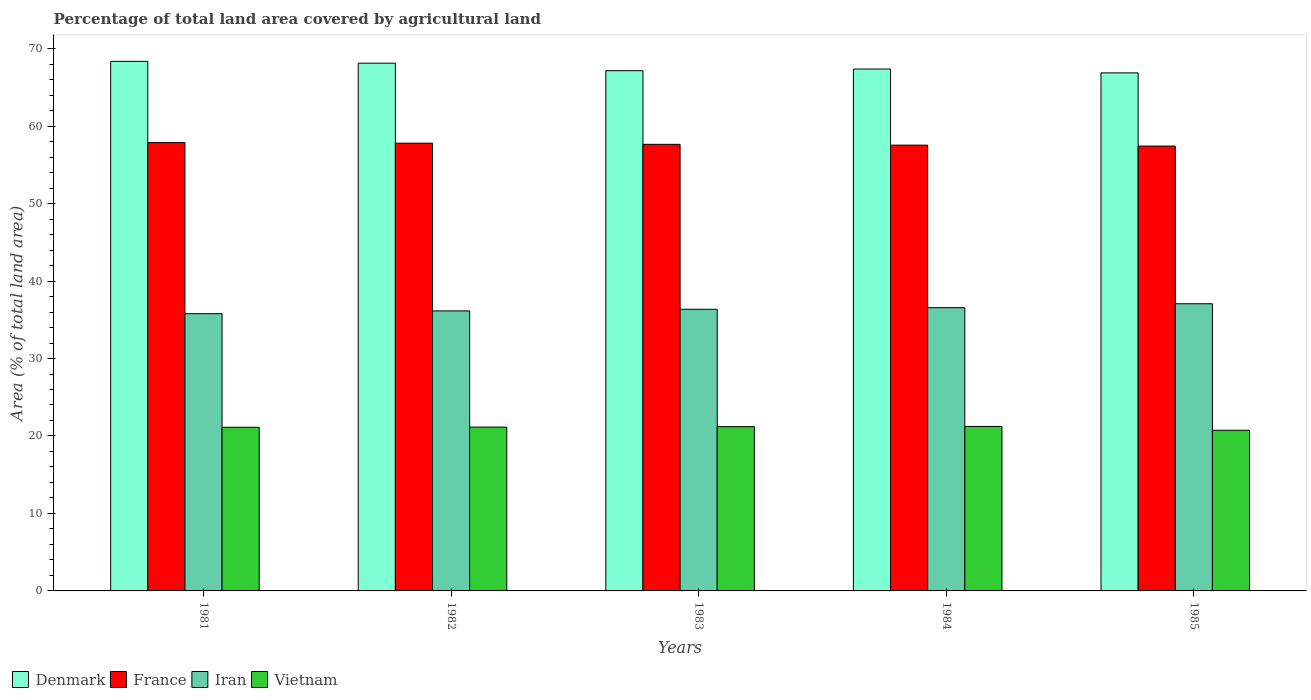Are the number of bars per tick equal to the number of legend labels?
Offer a terse response. Yes. What is the percentage of agricultural land in Denmark in 1981?
Give a very brief answer. 68.36. Across all years, what is the maximum percentage of agricultural land in Denmark?
Provide a succinct answer. 68.36. Across all years, what is the minimum percentage of agricultural land in Vietnam?
Offer a very short reply. 20.74. In which year was the percentage of agricultural land in Vietnam minimum?
Your answer should be compact. 1985. What is the total percentage of agricultural land in Vietnam in the graph?
Make the answer very short. 105.45. What is the difference between the percentage of agricultural land in France in 1982 and that in 1984?
Your answer should be compact. 0.25. What is the difference between the percentage of agricultural land in Vietnam in 1982 and the percentage of agricultural land in Denmark in 1984?
Keep it short and to the point. -46.22. What is the average percentage of agricultural land in Denmark per year?
Provide a succinct answer. 67.57. In the year 1981, what is the difference between the percentage of agricultural land in Vietnam and percentage of agricultural land in Iran?
Give a very brief answer. -14.66. In how many years, is the percentage of agricultural land in Vietnam greater than 66 %?
Keep it short and to the point. 0. What is the ratio of the percentage of agricultural land in France in 1983 to that in 1984?
Keep it short and to the point. 1. Is the percentage of agricultural land in Iran in 1981 less than that in 1983?
Your answer should be very brief. Yes. What is the difference between the highest and the second highest percentage of agricultural land in Denmark?
Keep it short and to the point. 0.24. What is the difference between the highest and the lowest percentage of agricultural land in Iran?
Provide a succinct answer. 1.28. In how many years, is the percentage of agricultural land in Denmark greater than the average percentage of agricultural land in Denmark taken over all years?
Your response must be concise. 2. Is the sum of the percentage of agricultural land in Iran in 1984 and 1985 greater than the maximum percentage of agricultural land in France across all years?
Offer a very short reply. Yes. Is it the case that in every year, the sum of the percentage of agricultural land in Iran and percentage of agricultural land in Denmark is greater than the sum of percentage of agricultural land in Vietnam and percentage of agricultural land in France?
Make the answer very short. Yes. What does the 4th bar from the left in 1985 represents?
Provide a short and direct response. Vietnam. What does the 2nd bar from the right in 1985 represents?
Ensure brevity in your answer.  Iran. Is it the case that in every year, the sum of the percentage of agricultural land in Denmark and percentage of agricultural land in Vietnam is greater than the percentage of agricultural land in France?
Keep it short and to the point. Yes. How many bars are there?
Give a very brief answer. 20. Are the values on the major ticks of Y-axis written in scientific E-notation?
Provide a short and direct response. No. Does the graph contain any zero values?
Your response must be concise. No. Does the graph contain grids?
Make the answer very short. No. Where does the legend appear in the graph?
Your response must be concise. Bottom left. How are the legend labels stacked?
Offer a very short reply. Horizontal. What is the title of the graph?
Offer a terse response. Percentage of total land area covered by agricultural land. What is the label or title of the X-axis?
Your answer should be compact. Years. What is the label or title of the Y-axis?
Provide a short and direct response. Area (% of total land area). What is the Area (% of total land area) in Denmark in 1981?
Offer a terse response. 68.36. What is the Area (% of total land area) of France in 1981?
Make the answer very short. 57.87. What is the Area (% of total land area) of Iran in 1981?
Provide a succinct answer. 35.79. What is the Area (% of total land area) of Vietnam in 1981?
Make the answer very short. 21.13. What is the Area (% of total land area) in Denmark in 1982?
Your answer should be very brief. 68.12. What is the Area (% of total land area) in France in 1982?
Offer a terse response. 57.79. What is the Area (% of total land area) in Iran in 1982?
Offer a terse response. 36.15. What is the Area (% of total land area) in Vietnam in 1982?
Your answer should be very brief. 21.15. What is the Area (% of total land area) of Denmark in 1983?
Your answer should be very brief. 67.15. What is the Area (% of total land area) of France in 1983?
Your answer should be very brief. 57.65. What is the Area (% of total land area) of Iran in 1983?
Keep it short and to the point. 36.36. What is the Area (% of total land area) of Vietnam in 1983?
Provide a succinct answer. 21.2. What is the Area (% of total land area) of Denmark in 1984?
Offer a terse response. 67.37. What is the Area (% of total land area) of France in 1984?
Provide a short and direct response. 57.54. What is the Area (% of total land area) of Iran in 1984?
Your response must be concise. 36.56. What is the Area (% of total land area) in Vietnam in 1984?
Provide a short and direct response. 21.23. What is the Area (% of total land area) of Denmark in 1985?
Your response must be concise. 66.87. What is the Area (% of total land area) of France in 1985?
Your answer should be compact. 57.42. What is the Area (% of total land area) in Iran in 1985?
Make the answer very short. 37.07. What is the Area (% of total land area) in Vietnam in 1985?
Provide a succinct answer. 20.74. Across all years, what is the maximum Area (% of total land area) in Denmark?
Provide a short and direct response. 68.36. Across all years, what is the maximum Area (% of total land area) of France?
Ensure brevity in your answer.  57.87. Across all years, what is the maximum Area (% of total land area) in Iran?
Keep it short and to the point. 37.07. Across all years, what is the maximum Area (% of total land area) in Vietnam?
Provide a short and direct response. 21.23. Across all years, what is the minimum Area (% of total land area) in Denmark?
Provide a succinct answer. 66.87. Across all years, what is the minimum Area (% of total land area) in France?
Keep it short and to the point. 57.42. Across all years, what is the minimum Area (% of total land area) of Iran?
Provide a short and direct response. 35.79. Across all years, what is the minimum Area (% of total land area) of Vietnam?
Keep it short and to the point. 20.74. What is the total Area (% of total land area) of Denmark in the graph?
Provide a short and direct response. 337.87. What is the total Area (% of total land area) in France in the graph?
Provide a succinct answer. 288.27. What is the total Area (% of total land area) in Iran in the graph?
Make the answer very short. 181.92. What is the total Area (% of total land area) of Vietnam in the graph?
Make the answer very short. 105.45. What is the difference between the Area (% of total land area) of Denmark in 1981 and that in 1982?
Provide a short and direct response. 0.24. What is the difference between the Area (% of total land area) in France in 1981 and that in 1982?
Provide a succinct answer. 0.07. What is the difference between the Area (% of total land area) of Iran in 1981 and that in 1982?
Your answer should be very brief. -0.36. What is the difference between the Area (% of total land area) in Vietnam in 1981 and that in 1982?
Your response must be concise. -0.02. What is the difference between the Area (% of total land area) of Denmark in 1981 and that in 1983?
Make the answer very short. 1.2. What is the difference between the Area (% of total land area) of France in 1981 and that in 1983?
Ensure brevity in your answer.  0.22. What is the difference between the Area (% of total land area) of Iran in 1981 and that in 1983?
Your answer should be compact. -0.57. What is the difference between the Area (% of total land area) in Vietnam in 1981 and that in 1983?
Give a very brief answer. -0.08. What is the difference between the Area (% of total land area) of France in 1981 and that in 1984?
Your answer should be very brief. 0.33. What is the difference between the Area (% of total land area) in Iran in 1981 and that in 1984?
Offer a very short reply. -0.77. What is the difference between the Area (% of total land area) of Vietnam in 1981 and that in 1984?
Offer a very short reply. -0.1. What is the difference between the Area (% of total land area) of Denmark in 1981 and that in 1985?
Keep it short and to the point. 1.49. What is the difference between the Area (% of total land area) in France in 1981 and that in 1985?
Offer a terse response. 0.45. What is the difference between the Area (% of total land area) of Iran in 1981 and that in 1985?
Ensure brevity in your answer.  -1.28. What is the difference between the Area (% of total land area) in Vietnam in 1981 and that in 1985?
Give a very brief answer. 0.39. What is the difference between the Area (% of total land area) in Denmark in 1982 and that in 1983?
Provide a succinct answer. 0.97. What is the difference between the Area (% of total land area) in France in 1982 and that in 1983?
Your answer should be very brief. 0.15. What is the difference between the Area (% of total land area) in Iran in 1982 and that in 1983?
Your response must be concise. -0.21. What is the difference between the Area (% of total land area) of Vietnam in 1982 and that in 1983?
Your answer should be very brief. -0.06. What is the difference between the Area (% of total land area) of Denmark in 1982 and that in 1984?
Keep it short and to the point. 0.76. What is the difference between the Area (% of total land area) of France in 1982 and that in 1984?
Your response must be concise. 0.25. What is the difference between the Area (% of total land area) of Iran in 1982 and that in 1984?
Offer a terse response. -0.41. What is the difference between the Area (% of total land area) of Vietnam in 1982 and that in 1984?
Provide a succinct answer. -0.08. What is the difference between the Area (% of total land area) in Denmark in 1982 and that in 1985?
Your answer should be compact. 1.25. What is the difference between the Area (% of total land area) in France in 1982 and that in 1985?
Provide a succinct answer. 0.37. What is the difference between the Area (% of total land area) of Iran in 1982 and that in 1985?
Provide a succinct answer. -0.92. What is the difference between the Area (% of total land area) in Vietnam in 1982 and that in 1985?
Your response must be concise. 0.41. What is the difference between the Area (% of total land area) of Denmark in 1983 and that in 1984?
Ensure brevity in your answer.  -0.21. What is the difference between the Area (% of total land area) of France in 1983 and that in 1984?
Provide a succinct answer. 0.1. What is the difference between the Area (% of total land area) of Iran in 1983 and that in 1984?
Give a very brief answer. -0.2. What is the difference between the Area (% of total land area) of Vietnam in 1983 and that in 1984?
Provide a short and direct response. -0.02. What is the difference between the Area (% of total land area) of Denmark in 1983 and that in 1985?
Your answer should be very brief. 0.28. What is the difference between the Area (% of total land area) in France in 1983 and that in 1985?
Ensure brevity in your answer.  0.22. What is the difference between the Area (% of total land area) in Iran in 1983 and that in 1985?
Keep it short and to the point. -0.71. What is the difference between the Area (% of total land area) in Vietnam in 1983 and that in 1985?
Keep it short and to the point. 0.47. What is the difference between the Area (% of total land area) in Denmark in 1984 and that in 1985?
Give a very brief answer. 0.5. What is the difference between the Area (% of total land area) of France in 1984 and that in 1985?
Ensure brevity in your answer.  0.12. What is the difference between the Area (% of total land area) of Iran in 1984 and that in 1985?
Provide a short and direct response. -0.51. What is the difference between the Area (% of total land area) in Vietnam in 1984 and that in 1985?
Your answer should be very brief. 0.49. What is the difference between the Area (% of total land area) in Denmark in 1981 and the Area (% of total land area) in France in 1982?
Provide a short and direct response. 10.56. What is the difference between the Area (% of total land area) in Denmark in 1981 and the Area (% of total land area) in Iran in 1982?
Make the answer very short. 32.21. What is the difference between the Area (% of total land area) of Denmark in 1981 and the Area (% of total land area) of Vietnam in 1982?
Make the answer very short. 47.21. What is the difference between the Area (% of total land area) in France in 1981 and the Area (% of total land area) in Iran in 1982?
Provide a succinct answer. 21.72. What is the difference between the Area (% of total land area) of France in 1981 and the Area (% of total land area) of Vietnam in 1982?
Make the answer very short. 36.72. What is the difference between the Area (% of total land area) of Iran in 1981 and the Area (% of total land area) of Vietnam in 1982?
Your answer should be very brief. 14.64. What is the difference between the Area (% of total land area) in Denmark in 1981 and the Area (% of total land area) in France in 1983?
Keep it short and to the point. 10.71. What is the difference between the Area (% of total land area) of Denmark in 1981 and the Area (% of total land area) of Iran in 1983?
Your answer should be very brief. 32. What is the difference between the Area (% of total land area) of Denmark in 1981 and the Area (% of total land area) of Vietnam in 1983?
Your response must be concise. 47.15. What is the difference between the Area (% of total land area) in France in 1981 and the Area (% of total land area) in Iran in 1983?
Give a very brief answer. 21.51. What is the difference between the Area (% of total land area) of France in 1981 and the Area (% of total land area) of Vietnam in 1983?
Your response must be concise. 36.66. What is the difference between the Area (% of total land area) of Iran in 1981 and the Area (% of total land area) of Vietnam in 1983?
Ensure brevity in your answer.  14.58. What is the difference between the Area (% of total land area) in Denmark in 1981 and the Area (% of total land area) in France in 1984?
Make the answer very short. 10.82. What is the difference between the Area (% of total land area) of Denmark in 1981 and the Area (% of total land area) of Iran in 1984?
Your response must be concise. 31.8. What is the difference between the Area (% of total land area) of Denmark in 1981 and the Area (% of total land area) of Vietnam in 1984?
Your answer should be very brief. 47.13. What is the difference between the Area (% of total land area) of France in 1981 and the Area (% of total land area) of Iran in 1984?
Give a very brief answer. 21.31. What is the difference between the Area (% of total land area) of France in 1981 and the Area (% of total land area) of Vietnam in 1984?
Give a very brief answer. 36.64. What is the difference between the Area (% of total land area) of Iran in 1981 and the Area (% of total land area) of Vietnam in 1984?
Give a very brief answer. 14.56. What is the difference between the Area (% of total land area) in Denmark in 1981 and the Area (% of total land area) in France in 1985?
Give a very brief answer. 10.94. What is the difference between the Area (% of total land area) in Denmark in 1981 and the Area (% of total land area) in Iran in 1985?
Offer a terse response. 31.29. What is the difference between the Area (% of total land area) of Denmark in 1981 and the Area (% of total land area) of Vietnam in 1985?
Offer a very short reply. 47.62. What is the difference between the Area (% of total land area) of France in 1981 and the Area (% of total land area) of Iran in 1985?
Your answer should be very brief. 20.8. What is the difference between the Area (% of total land area) in France in 1981 and the Area (% of total land area) in Vietnam in 1985?
Your answer should be compact. 37.13. What is the difference between the Area (% of total land area) of Iran in 1981 and the Area (% of total land area) of Vietnam in 1985?
Ensure brevity in your answer.  15.05. What is the difference between the Area (% of total land area) in Denmark in 1982 and the Area (% of total land area) in France in 1983?
Your response must be concise. 10.48. What is the difference between the Area (% of total land area) of Denmark in 1982 and the Area (% of total land area) of Iran in 1983?
Offer a terse response. 31.76. What is the difference between the Area (% of total land area) of Denmark in 1982 and the Area (% of total land area) of Vietnam in 1983?
Offer a very short reply. 46.92. What is the difference between the Area (% of total land area) of France in 1982 and the Area (% of total land area) of Iran in 1983?
Give a very brief answer. 21.44. What is the difference between the Area (% of total land area) of France in 1982 and the Area (% of total land area) of Vietnam in 1983?
Provide a short and direct response. 36.59. What is the difference between the Area (% of total land area) in Iran in 1982 and the Area (% of total land area) in Vietnam in 1983?
Provide a succinct answer. 14.94. What is the difference between the Area (% of total land area) of Denmark in 1982 and the Area (% of total land area) of France in 1984?
Your response must be concise. 10.58. What is the difference between the Area (% of total land area) in Denmark in 1982 and the Area (% of total land area) in Iran in 1984?
Your response must be concise. 31.56. What is the difference between the Area (% of total land area) of Denmark in 1982 and the Area (% of total land area) of Vietnam in 1984?
Offer a very short reply. 46.89. What is the difference between the Area (% of total land area) in France in 1982 and the Area (% of total land area) in Iran in 1984?
Provide a short and direct response. 21.23. What is the difference between the Area (% of total land area) in France in 1982 and the Area (% of total land area) in Vietnam in 1984?
Your response must be concise. 36.56. What is the difference between the Area (% of total land area) of Iran in 1982 and the Area (% of total land area) of Vietnam in 1984?
Make the answer very short. 14.92. What is the difference between the Area (% of total land area) of Denmark in 1982 and the Area (% of total land area) of France in 1985?
Offer a terse response. 10.7. What is the difference between the Area (% of total land area) in Denmark in 1982 and the Area (% of total land area) in Iran in 1985?
Your answer should be compact. 31.05. What is the difference between the Area (% of total land area) of Denmark in 1982 and the Area (% of total land area) of Vietnam in 1985?
Your answer should be very brief. 47.38. What is the difference between the Area (% of total land area) of France in 1982 and the Area (% of total land area) of Iran in 1985?
Keep it short and to the point. 20.72. What is the difference between the Area (% of total land area) of France in 1982 and the Area (% of total land area) of Vietnam in 1985?
Your answer should be very brief. 37.06. What is the difference between the Area (% of total land area) of Iran in 1982 and the Area (% of total land area) of Vietnam in 1985?
Your answer should be compact. 15.41. What is the difference between the Area (% of total land area) in Denmark in 1983 and the Area (% of total land area) in France in 1984?
Make the answer very short. 9.61. What is the difference between the Area (% of total land area) of Denmark in 1983 and the Area (% of total land area) of Iran in 1984?
Provide a succinct answer. 30.59. What is the difference between the Area (% of total land area) of Denmark in 1983 and the Area (% of total land area) of Vietnam in 1984?
Provide a short and direct response. 45.92. What is the difference between the Area (% of total land area) of France in 1983 and the Area (% of total land area) of Iran in 1984?
Provide a short and direct response. 21.09. What is the difference between the Area (% of total land area) in France in 1983 and the Area (% of total land area) in Vietnam in 1984?
Provide a succinct answer. 36.42. What is the difference between the Area (% of total land area) of Iran in 1983 and the Area (% of total land area) of Vietnam in 1984?
Provide a succinct answer. 15.13. What is the difference between the Area (% of total land area) in Denmark in 1983 and the Area (% of total land area) in France in 1985?
Give a very brief answer. 9.73. What is the difference between the Area (% of total land area) of Denmark in 1983 and the Area (% of total land area) of Iran in 1985?
Keep it short and to the point. 30.08. What is the difference between the Area (% of total land area) of Denmark in 1983 and the Area (% of total land area) of Vietnam in 1985?
Your answer should be compact. 46.42. What is the difference between the Area (% of total land area) of France in 1983 and the Area (% of total land area) of Iran in 1985?
Offer a very short reply. 20.58. What is the difference between the Area (% of total land area) of France in 1983 and the Area (% of total land area) of Vietnam in 1985?
Your response must be concise. 36.91. What is the difference between the Area (% of total land area) of Iran in 1983 and the Area (% of total land area) of Vietnam in 1985?
Your answer should be very brief. 15.62. What is the difference between the Area (% of total land area) of Denmark in 1984 and the Area (% of total land area) of France in 1985?
Ensure brevity in your answer.  9.95. What is the difference between the Area (% of total land area) of Denmark in 1984 and the Area (% of total land area) of Iran in 1985?
Your answer should be compact. 30.3. What is the difference between the Area (% of total land area) of Denmark in 1984 and the Area (% of total land area) of Vietnam in 1985?
Give a very brief answer. 46.63. What is the difference between the Area (% of total land area) in France in 1984 and the Area (% of total land area) in Iran in 1985?
Ensure brevity in your answer.  20.47. What is the difference between the Area (% of total land area) in France in 1984 and the Area (% of total land area) in Vietnam in 1985?
Your answer should be very brief. 36.8. What is the difference between the Area (% of total land area) in Iran in 1984 and the Area (% of total land area) in Vietnam in 1985?
Ensure brevity in your answer.  15.82. What is the average Area (% of total land area) of Denmark per year?
Make the answer very short. 67.57. What is the average Area (% of total land area) of France per year?
Offer a terse response. 57.65. What is the average Area (% of total land area) of Iran per year?
Your answer should be compact. 36.38. What is the average Area (% of total land area) in Vietnam per year?
Offer a very short reply. 21.09. In the year 1981, what is the difference between the Area (% of total land area) in Denmark and Area (% of total land area) in France?
Keep it short and to the point. 10.49. In the year 1981, what is the difference between the Area (% of total land area) of Denmark and Area (% of total land area) of Iran?
Offer a very short reply. 32.57. In the year 1981, what is the difference between the Area (% of total land area) in Denmark and Area (% of total land area) in Vietnam?
Your response must be concise. 47.23. In the year 1981, what is the difference between the Area (% of total land area) in France and Area (% of total land area) in Iran?
Your answer should be compact. 22.08. In the year 1981, what is the difference between the Area (% of total land area) of France and Area (% of total land area) of Vietnam?
Offer a terse response. 36.74. In the year 1981, what is the difference between the Area (% of total land area) of Iran and Area (% of total land area) of Vietnam?
Make the answer very short. 14.66. In the year 1982, what is the difference between the Area (% of total land area) of Denmark and Area (% of total land area) of France?
Provide a succinct answer. 10.33. In the year 1982, what is the difference between the Area (% of total land area) of Denmark and Area (% of total land area) of Iran?
Ensure brevity in your answer.  31.97. In the year 1982, what is the difference between the Area (% of total land area) of Denmark and Area (% of total land area) of Vietnam?
Your answer should be very brief. 46.97. In the year 1982, what is the difference between the Area (% of total land area) in France and Area (% of total land area) in Iran?
Your answer should be compact. 21.65. In the year 1982, what is the difference between the Area (% of total land area) of France and Area (% of total land area) of Vietnam?
Your response must be concise. 36.64. In the year 1982, what is the difference between the Area (% of total land area) of Iran and Area (% of total land area) of Vietnam?
Your answer should be very brief. 15. In the year 1983, what is the difference between the Area (% of total land area) of Denmark and Area (% of total land area) of France?
Provide a succinct answer. 9.51. In the year 1983, what is the difference between the Area (% of total land area) in Denmark and Area (% of total land area) in Iran?
Ensure brevity in your answer.  30.8. In the year 1983, what is the difference between the Area (% of total land area) of Denmark and Area (% of total land area) of Vietnam?
Make the answer very short. 45.95. In the year 1983, what is the difference between the Area (% of total land area) in France and Area (% of total land area) in Iran?
Provide a succinct answer. 21.29. In the year 1983, what is the difference between the Area (% of total land area) in France and Area (% of total land area) in Vietnam?
Provide a succinct answer. 36.44. In the year 1983, what is the difference between the Area (% of total land area) of Iran and Area (% of total land area) of Vietnam?
Provide a short and direct response. 15.15. In the year 1984, what is the difference between the Area (% of total land area) in Denmark and Area (% of total land area) in France?
Give a very brief answer. 9.82. In the year 1984, what is the difference between the Area (% of total land area) of Denmark and Area (% of total land area) of Iran?
Offer a terse response. 30.81. In the year 1984, what is the difference between the Area (% of total land area) of Denmark and Area (% of total land area) of Vietnam?
Give a very brief answer. 46.14. In the year 1984, what is the difference between the Area (% of total land area) of France and Area (% of total land area) of Iran?
Provide a short and direct response. 20.98. In the year 1984, what is the difference between the Area (% of total land area) of France and Area (% of total land area) of Vietnam?
Your answer should be compact. 36.31. In the year 1984, what is the difference between the Area (% of total land area) of Iran and Area (% of total land area) of Vietnam?
Provide a short and direct response. 15.33. In the year 1985, what is the difference between the Area (% of total land area) in Denmark and Area (% of total land area) in France?
Your answer should be compact. 9.45. In the year 1985, what is the difference between the Area (% of total land area) of Denmark and Area (% of total land area) of Iran?
Provide a short and direct response. 29.8. In the year 1985, what is the difference between the Area (% of total land area) in Denmark and Area (% of total land area) in Vietnam?
Provide a short and direct response. 46.13. In the year 1985, what is the difference between the Area (% of total land area) in France and Area (% of total land area) in Iran?
Make the answer very short. 20.35. In the year 1985, what is the difference between the Area (% of total land area) in France and Area (% of total land area) in Vietnam?
Provide a succinct answer. 36.68. In the year 1985, what is the difference between the Area (% of total land area) in Iran and Area (% of total land area) in Vietnam?
Make the answer very short. 16.33. What is the ratio of the Area (% of total land area) of France in 1981 to that in 1982?
Give a very brief answer. 1. What is the ratio of the Area (% of total land area) in Vietnam in 1981 to that in 1982?
Provide a succinct answer. 1. What is the ratio of the Area (% of total land area) of Denmark in 1981 to that in 1983?
Provide a short and direct response. 1.02. What is the ratio of the Area (% of total land area) in Iran in 1981 to that in 1983?
Keep it short and to the point. 0.98. What is the ratio of the Area (% of total land area) in Vietnam in 1981 to that in 1983?
Make the answer very short. 1. What is the ratio of the Area (% of total land area) of Denmark in 1981 to that in 1984?
Provide a succinct answer. 1.01. What is the ratio of the Area (% of total land area) of Iran in 1981 to that in 1984?
Make the answer very short. 0.98. What is the ratio of the Area (% of total land area) in Vietnam in 1981 to that in 1984?
Ensure brevity in your answer.  1. What is the ratio of the Area (% of total land area) of Denmark in 1981 to that in 1985?
Offer a terse response. 1.02. What is the ratio of the Area (% of total land area) in Iran in 1981 to that in 1985?
Ensure brevity in your answer.  0.97. What is the ratio of the Area (% of total land area) of Vietnam in 1981 to that in 1985?
Ensure brevity in your answer.  1.02. What is the ratio of the Area (% of total land area) in Denmark in 1982 to that in 1983?
Give a very brief answer. 1.01. What is the ratio of the Area (% of total land area) in France in 1982 to that in 1983?
Give a very brief answer. 1. What is the ratio of the Area (% of total land area) in Iran in 1982 to that in 1983?
Provide a succinct answer. 0.99. What is the ratio of the Area (% of total land area) of Vietnam in 1982 to that in 1983?
Offer a very short reply. 1. What is the ratio of the Area (% of total land area) of Denmark in 1982 to that in 1984?
Your answer should be very brief. 1.01. What is the ratio of the Area (% of total land area) of Iran in 1982 to that in 1984?
Provide a short and direct response. 0.99. What is the ratio of the Area (% of total land area) in Vietnam in 1982 to that in 1984?
Provide a succinct answer. 1. What is the ratio of the Area (% of total land area) of Denmark in 1982 to that in 1985?
Offer a very short reply. 1.02. What is the ratio of the Area (% of total land area) in France in 1982 to that in 1985?
Ensure brevity in your answer.  1.01. What is the ratio of the Area (% of total land area) of Iran in 1982 to that in 1985?
Make the answer very short. 0.98. What is the ratio of the Area (% of total land area) of Vietnam in 1982 to that in 1985?
Keep it short and to the point. 1.02. What is the ratio of the Area (% of total land area) in Denmark in 1983 to that in 1984?
Provide a short and direct response. 1. What is the ratio of the Area (% of total land area) of Iran in 1983 to that in 1984?
Offer a very short reply. 0.99. What is the ratio of the Area (% of total land area) of Vietnam in 1983 to that in 1984?
Give a very brief answer. 1. What is the ratio of the Area (% of total land area) of Denmark in 1983 to that in 1985?
Offer a very short reply. 1. What is the ratio of the Area (% of total land area) in Iran in 1983 to that in 1985?
Your response must be concise. 0.98. What is the ratio of the Area (% of total land area) in Vietnam in 1983 to that in 1985?
Keep it short and to the point. 1.02. What is the ratio of the Area (% of total land area) in Denmark in 1984 to that in 1985?
Keep it short and to the point. 1.01. What is the ratio of the Area (% of total land area) of France in 1984 to that in 1985?
Your answer should be very brief. 1. What is the ratio of the Area (% of total land area) in Iran in 1984 to that in 1985?
Keep it short and to the point. 0.99. What is the ratio of the Area (% of total land area) in Vietnam in 1984 to that in 1985?
Give a very brief answer. 1.02. What is the difference between the highest and the second highest Area (% of total land area) in Denmark?
Your response must be concise. 0.24. What is the difference between the highest and the second highest Area (% of total land area) of France?
Offer a very short reply. 0.07. What is the difference between the highest and the second highest Area (% of total land area) in Iran?
Ensure brevity in your answer.  0.51. What is the difference between the highest and the second highest Area (% of total land area) of Vietnam?
Keep it short and to the point. 0.02. What is the difference between the highest and the lowest Area (% of total land area) in Denmark?
Your answer should be compact. 1.49. What is the difference between the highest and the lowest Area (% of total land area) in France?
Provide a succinct answer. 0.45. What is the difference between the highest and the lowest Area (% of total land area) in Iran?
Provide a succinct answer. 1.28. What is the difference between the highest and the lowest Area (% of total land area) in Vietnam?
Provide a succinct answer. 0.49. 